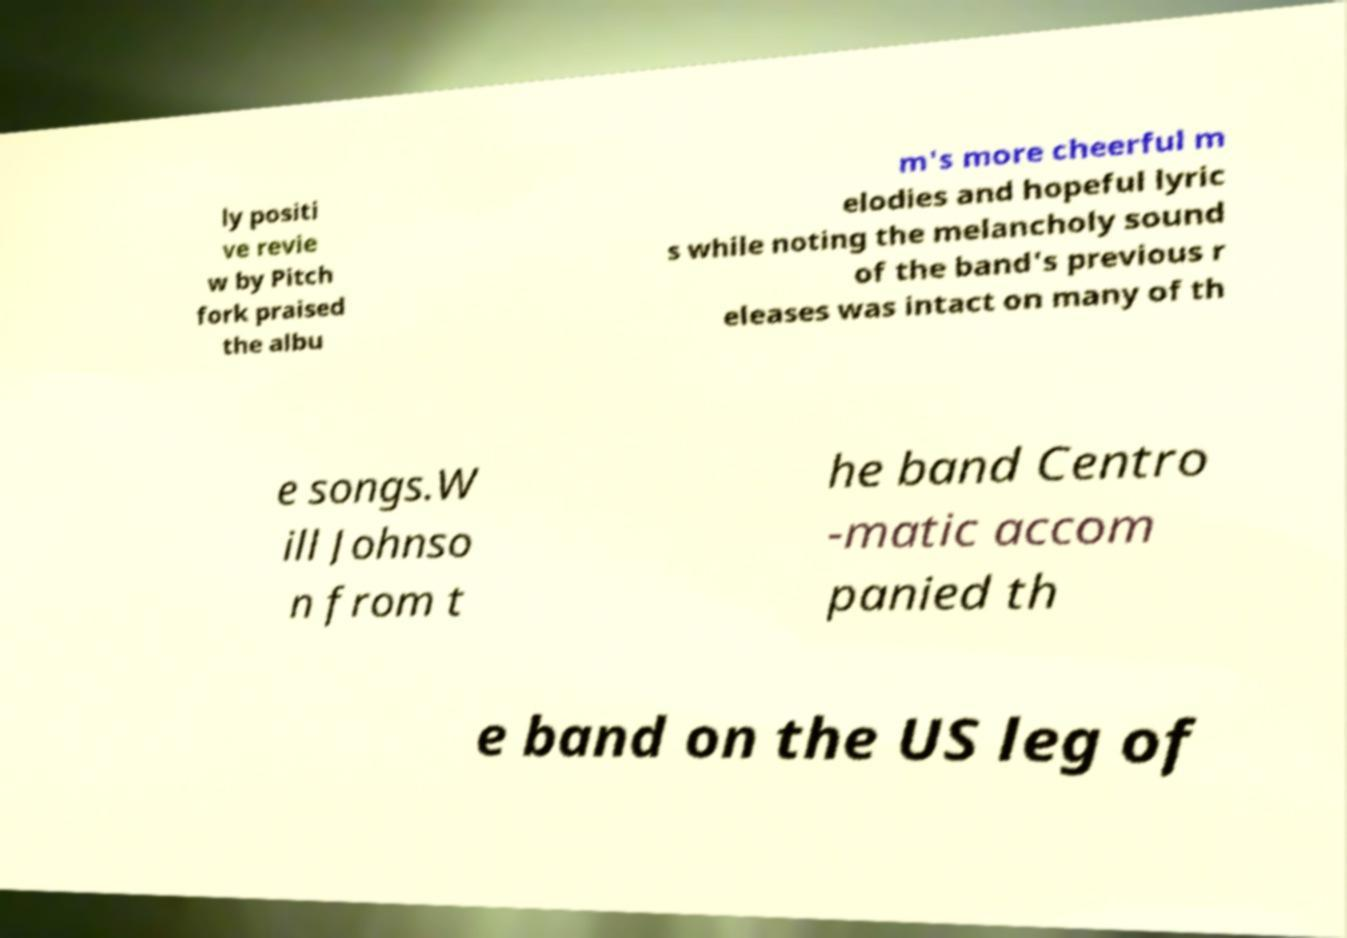I need the written content from this picture converted into text. Can you do that? ly positi ve revie w by Pitch fork praised the albu m's more cheerful m elodies and hopeful lyric s while noting the melancholy sound of the band's previous r eleases was intact on many of th e songs.W ill Johnso n from t he band Centro -matic accom panied th e band on the US leg of 